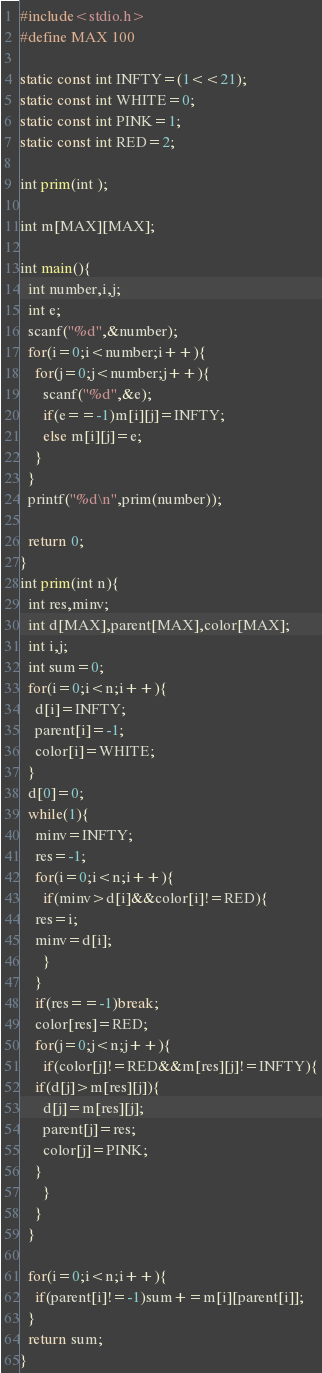<code> <loc_0><loc_0><loc_500><loc_500><_C_>#include<stdio.h>
#define MAX 100

static const int INFTY=(1<<21);
static const int WHITE=0;
static const int PINK=1;
static const int RED=2;

int prim(int );

int m[MAX][MAX];

int main(){
  int number,i,j;
  int e;
  scanf("%d",&number);
  for(i=0;i<number;i++){
    for(j=0;j<number;j++){
      scanf("%d",&e);
      if(e==-1)m[i][j]=INFTY;
      else m[i][j]=e;
    }
  }
  printf("%d\n",prim(number));
   
  return 0;
}
int prim(int n){
  int res,minv;
  int d[MAX],parent[MAX],color[MAX];
  int i,j;
  int sum=0;
  for(i=0;i<n;i++){
    d[i]=INFTY;
    parent[i]=-1;
    color[i]=WHITE;
  }
  d[0]=0;
  while(1){
    minv=INFTY;
    res=-1;
    for(i=0;i<n;i++){
      if(minv>d[i]&&color[i]!=RED){
	res=i;
	minv=d[i];
      }
    }
    if(res==-1)break;
    color[res]=RED;
    for(j=0;j<n;j++){
      if(color[j]!=RED&&m[res][j]!=INFTY){
	if(d[j]>m[res][j]){
	  d[j]=m[res][j];
	  parent[j]=res;
	  color[j]=PINK;
	}
      }
    }
  }

  for(i=0;i<n;i++){
    if(parent[i]!=-1)sum+=m[i][parent[i]];
  }
  return sum;
}</code> 